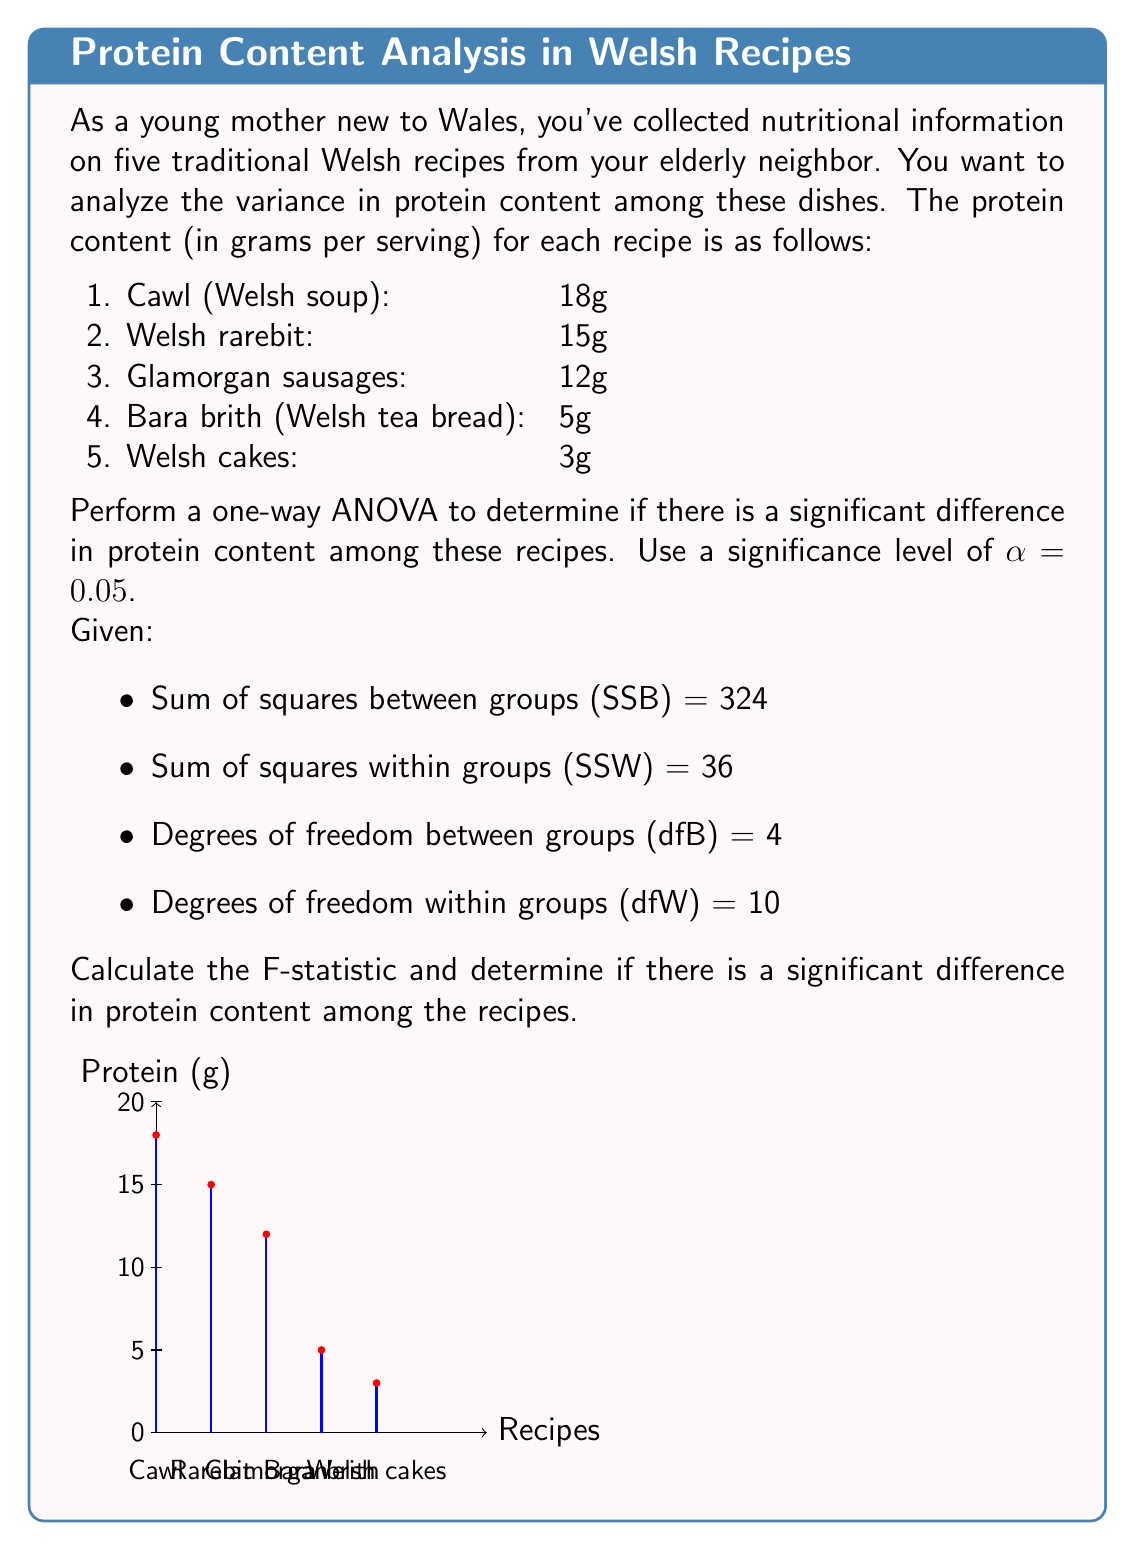Help me with this question. To perform a one-way ANOVA and calculate the F-statistic, we'll follow these steps:

1. Calculate the mean squares:
   Mean Square Between (MSB) = SSB / dfB
   $$MSB = \frac{324}{4} = 81$$
   
   Mean Square Within (MSW) = SSW / dfW
   $$MSW = \frac{36}{10} = 3.6$$

2. Calculate the F-statistic:
   $$F = \frac{MSB}{MSW} = \frac{81}{3.6} = 22.5$$

3. Determine the critical F-value:
   With α = 0.05, dfB = 4, and dfW = 10, we can look up the critical F-value in an F-distribution table.
   The critical F-value is approximately 3.48.

4. Compare the calculated F-statistic to the critical F-value:
   Since 22.5 > 3.48, we reject the null hypothesis.

5. Interpret the results:
   There is a statistically significant difference in protein content among the five traditional Welsh recipes at the 0.05 significance level.

The large F-statistic (22.5) indicates that the variation between groups (recipes) is much larger than the variation within groups, suggesting substantial differences in protein content among the recipes.
Answer: F = 22.5; Significant difference in protein content (p < 0.05) 